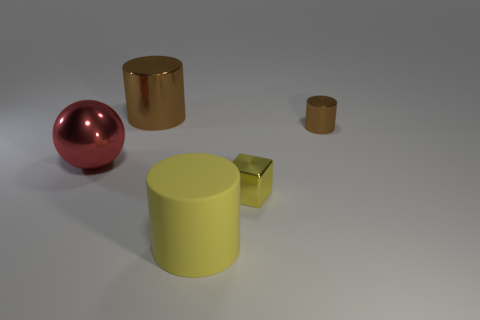Are there any other things that have the same material as the yellow cylinder?
Provide a succinct answer. No. There is a object that is to the right of the yellow cylinder and behind the block; what is it made of?
Offer a very short reply. Metal. What color is the small shiny thing in front of the ball?
Your answer should be compact. Yellow. Is the number of brown cylinders to the left of the yellow cylinder greater than the number of large cyan blocks?
Give a very brief answer. Yes. What number of other things are the same size as the metal ball?
Make the answer very short. 2. What number of large objects are in front of the tiny yellow metallic object?
Ensure brevity in your answer.  1. Is the number of large metal objects that are to the right of the cube the same as the number of shiny cylinders that are to the right of the yellow matte cylinder?
Provide a succinct answer. No. There is another rubber thing that is the same shape as the large brown thing; what size is it?
Your response must be concise. Large. The big metallic object that is in front of the small brown cylinder has what shape?
Your answer should be compact. Sphere. Is the material of the brown thing right of the rubber thing the same as the yellow thing that is to the right of the yellow matte thing?
Your answer should be compact. Yes. 